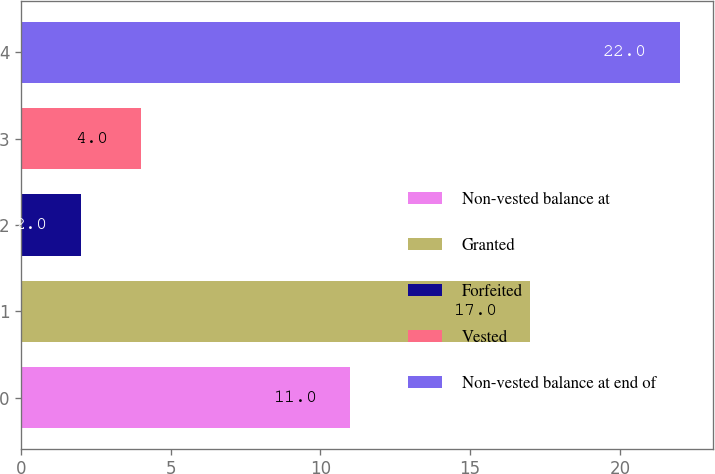Convert chart to OTSL. <chart><loc_0><loc_0><loc_500><loc_500><bar_chart><fcel>Non-vested balance at<fcel>Granted<fcel>Forfeited<fcel>Vested<fcel>Non-vested balance at end of<nl><fcel>11<fcel>17<fcel>2<fcel>4<fcel>22<nl></chart> 